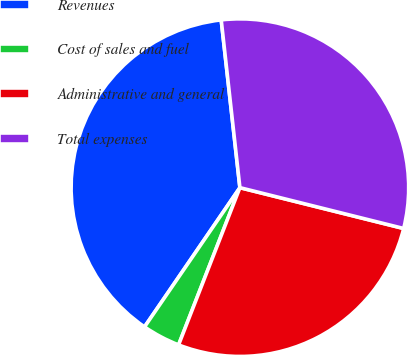Convert chart to OTSL. <chart><loc_0><loc_0><loc_500><loc_500><pie_chart><fcel>Revenues<fcel>Cost of sales and fuel<fcel>Administrative and general<fcel>Total expenses<nl><fcel>38.68%<fcel>3.64%<fcel>27.03%<fcel>30.66%<nl></chart> 